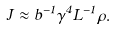<formula> <loc_0><loc_0><loc_500><loc_500>J \approx b ^ { - 1 } \gamma ^ { 4 } L ^ { - 1 } \rho .</formula> 